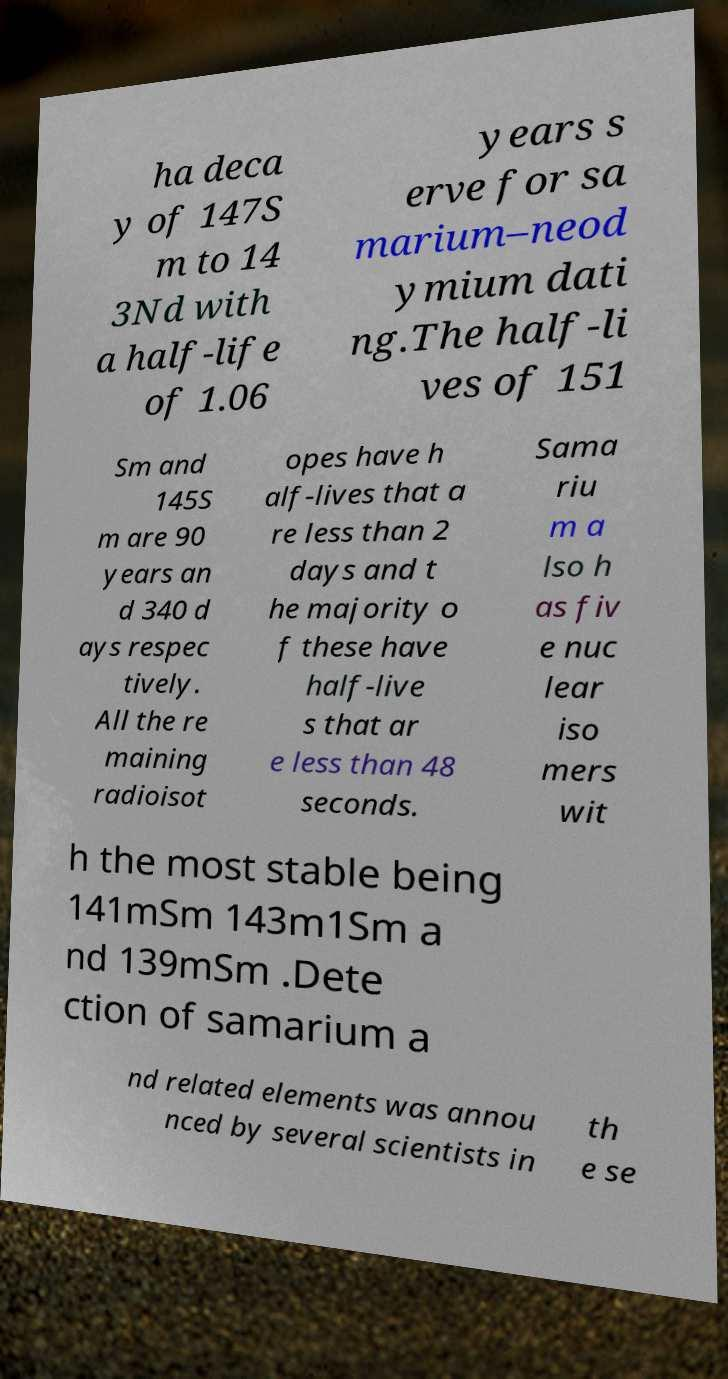I need the written content from this picture converted into text. Can you do that? ha deca y of 147S m to 14 3Nd with a half-life of 1.06 years s erve for sa marium–neod ymium dati ng.The half-li ves of 151 Sm and 145S m are 90 years an d 340 d ays respec tively. All the re maining radioisot opes have h alf-lives that a re less than 2 days and t he majority o f these have half-live s that ar e less than 48 seconds. Sama riu m a lso h as fiv e nuc lear iso mers wit h the most stable being 141mSm 143m1Sm a nd 139mSm .Dete ction of samarium a nd related elements was annou nced by several scientists in th e se 